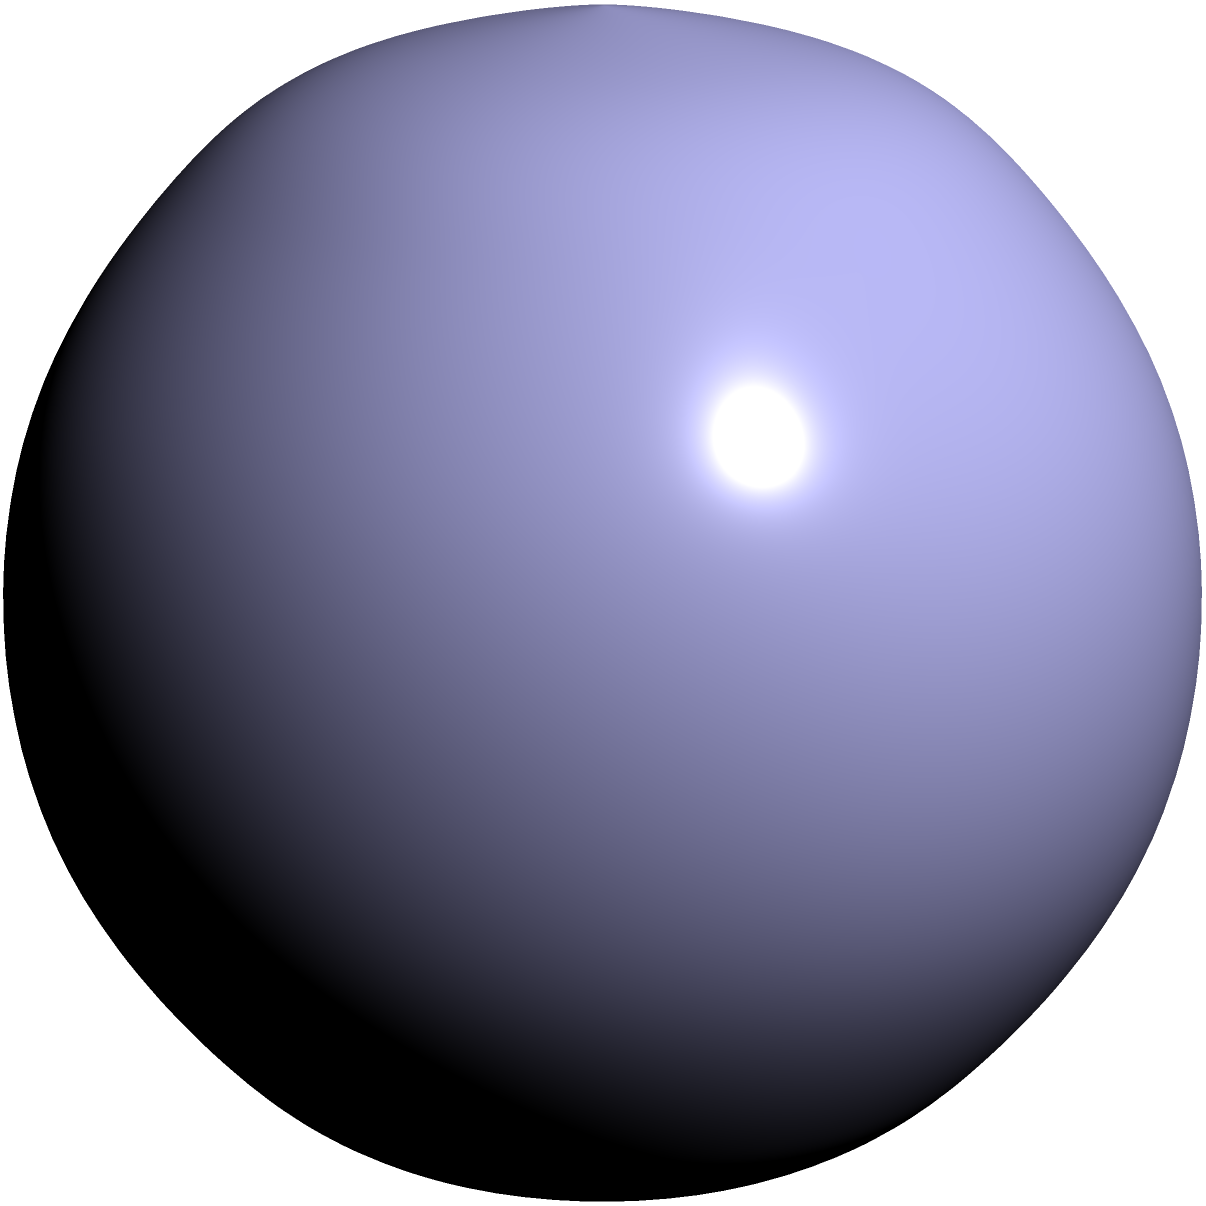As a Calgary Roughnecks enthusiast, you know that the lacrosse ball is crucial to the game. If a regulation lacrosse ball has a diameter of 2.5 inches, what is its surface area in square inches? Round your answer to two decimal places. Let's approach this step-by-step:

1) The lacrosse ball is a sphere. The formula for the surface area of a sphere is:

   $$A = 4\pi r^2$$

   where $A$ is the surface area and $r$ is the radius.

2) We're given the diameter, which is 2.5 inches. The radius is half of the diameter:

   $$r = \frac{2.5}{2} = 1.25\text{ inches}$$

3) Now, let's substitute this into our formula:

   $$A = 4\pi (1.25)^2$$

4) Let's calculate:
   
   $$A = 4\pi (1.5625)$$
   $$A = 6.25\pi$$

5) Using a calculator or approximating $\pi$ as 3.14159:

   $$A \approx 19.6349\text{ square inches}$$

6) Rounding to two decimal places:

   $$A \approx 19.63\text{ square inches}$$
Answer: 19.63 square inches 